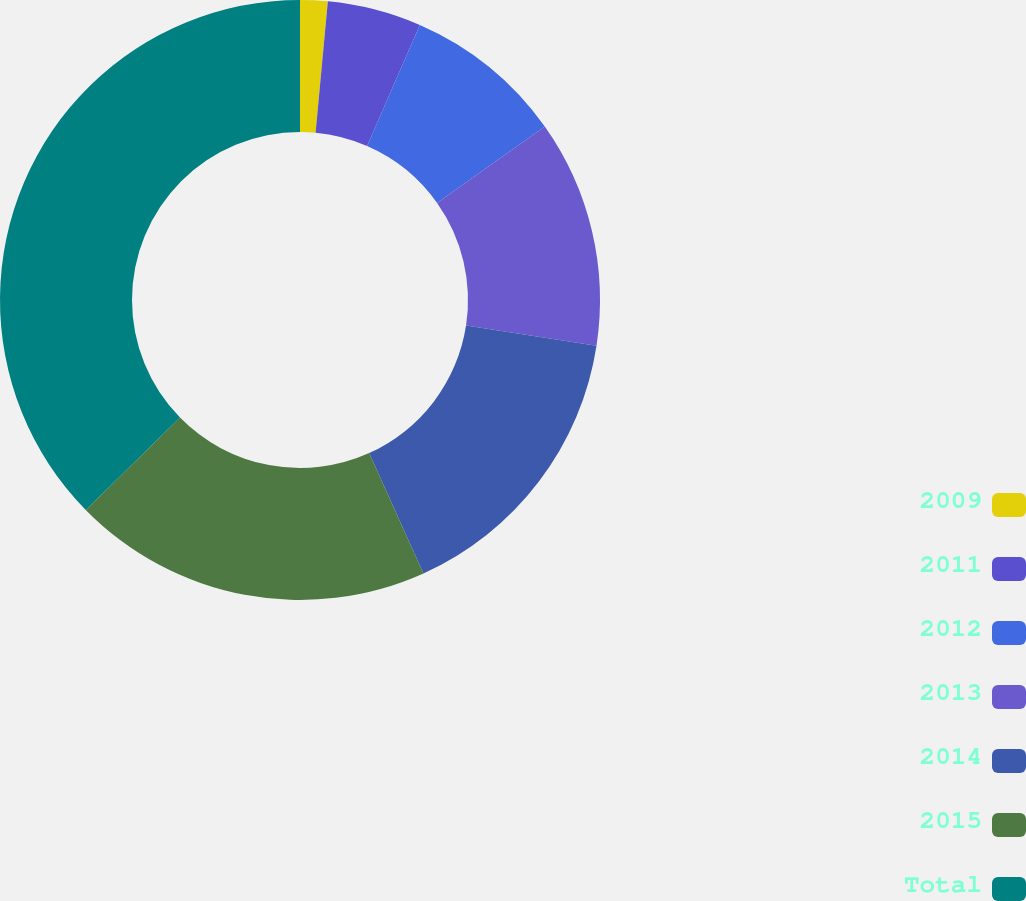Convert chart to OTSL. <chart><loc_0><loc_0><loc_500><loc_500><pie_chart><fcel>2009<fcel>2011<fcel>2012<fcel>2013<fcel>2014<fcel>2015<fcel>Total<nl><fcel>1.48%<fcel>5.06%<fcel>8.65%<fcel>12.24%<fcel>15.82%<fcel>19.41%<fcel>37.34%<nl></chart> 